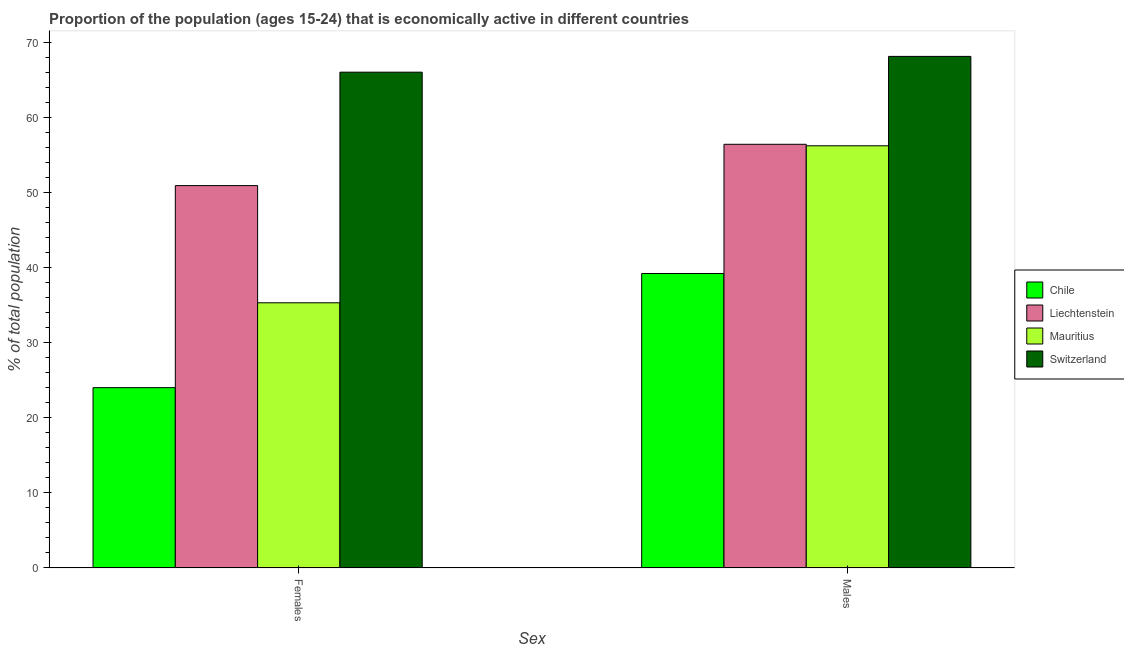How many groups of bars are there?
Ensure brevity in your answer.  2. Are the number of bars per tick equal to the number of legend labels?
Your answer should be very brief. Yes. How many bars are there on the 2nd tick from the right?
Provide a short and direct response. 4. What is the label of the 2nd group of bars from the left?
Offer a terse response. Males. Across all countries, what is the maximum percentage of economically active male population?
Your answer should be very brief. 68.1. Across all countries, what is the minimum percentage of economically active female population?
Give a very brief answer. 24. In which country was the percentage of economically active male population maximum?
Provide a short and direct response. Switzerland. What is the total percentage of economically active male population in the graph?
Offer a very short reply. 219.9. What is the difference between the percentage of economically active male population in Chile and that in Liechtenstein?
Your response must be concise. -17.2. What is the difference between the percentage of economically active female population in Chile and the percentage of economically active male population in Switzerland?
Your answer should be compact. -44.1. What is the average percentage of economically active female population per country?
Your answer should be compact. 44.05. What is the difference between the percentage of economically active male population and percentage of economically active female population in Mauritius?
Offer a very short reply. 20.9. What is the ratio of the percentage of economically active male population in Liechtenstein to that in Chile?
Your answer should be compact. 1.44. What does the 2nd bar from the left in Females represents?
Give a very brief answer. Liechtenstein. What does the 1st bar from the right in Females represents?
Make the answer very short. Switzerland. How many bars are there?
Your response must be concise. 8. Are all the bars in the graph horizontal?
Your answer should be very brief. No. Are the values on the major ticks of Y-axis written in scientific E-notation?
Keep it short and to the point. No. How are the legend labels stacked?
Offer a very short reply. Vertical. What is the title of the graph?
Ensure brevity in your answer.  Proportion of the population (ages 15-24) that is economically active in different countries. What is the label or title of the X-axis?
Keep it short and to the point. Sex. What is the label or title of the Y-axis?
Your answer should be very brief. % of total population. What is the % of total population of Chile in Females?
Your answer should be compact. 24. What is the % of total population in Liechtenstein in Females?
Your answer should be very brief. 50.9. What is the % of total population of Mauritius in Females?
Ensure brevity in your answer.  35.3. What is the % of total population in Chile in Males?
Ensure brevity in your answer.  39.2. What is the % of total population of Liechtenstein in Males?
Your answer should be very brief. 56.4. What is the % of total population in Mauritius in Males?
Give a very brief answer. 56.2. What is the % of total population of Switzerland in Males?
Make the answer very short. 68.1. Across all Sex, what is the maximum % of total population of Chile?
Your answer should be compact. 39.2. Across all Sex, what is the maximum % of total population of Liechtenstein?
Offer a very short reply. 56.4. Across all Sex, what is the maximum % of total population in Mauritius?
Your response must be concise. 56.2. Across all Sex, what is the maximum % of total population of Switzerland?
Provide a succinct answer. 68.1. Across all Sex, what is the minimum % of total population of Chile?
Keep it short and to the point. 24. Across all Sex, what is the minimum % of total population in Liechtenstein?
Ensure brevity in your answer.  50.9. Across all Sex, what is the minimum % of total population of Mauritius?
Provide a succinct answer. 35.3. Across all Sex, what is the minimum % of total population of Switzerland?
Give a very brief answer. 66. What is the total % of total population in Chile in the graph?
Make the answer very short. 63.2. What is the total % of total population in Liechtenstein in the graph?
Give a very brief answer. 107.3. What is the total % of total population in Mauritius in the graph?
Keep it short and to the point. 91.5. What is the total % of total population in Switzerland in the graph?
Give a very brief answer. 134.1. What is the difference between the % of total population in Chile in Females and that in Males?
Offer a terse response. -15.2. What is the difference between the % of total population of Liechtenstein in Females and that in Males?
Offer a very short reply. -5.5. What is the difference between the % of total population of Mauritius in Females and that in Males?
Your response must be concise. -20.9. What is the difference between the % of total population of Chile in Females and the % of total population of Liechtenstein in Males?
Ensure brevity in your answer.  -32.4. What is the difference between the % of total population of Chile in Females and the % of total population of Mauritius in Males?
Your answer should be very brief. -32.2. What is the difference between the % of total population in Chile in Females and the % of total population in Switzerland in Males?
Provide a short and direct response. -44.1. What is the difference between the % of total population in Liechtenstein in Females and the % of total population in Mauritius in Males?
Provide a succinct answer. -5.3. What is the difference between the % of total population in Liechtenstein in Females and the % of total population in Switzerland in Males?
Your response must be concise. -17.2. What is the difference between the % of total population in Mauritius in Females and the % of total population in Switzerland in Males?
Provide a short and direct response. -32.8. What is the average % of total population of Chile per Sex?
Your response must be concise. 31.6. What is the average % of total population in Liechtenstein per Sex?
Make the answer very short. 53.65. What is the average % of total population of Mauritius per Sex?
Offer a very short reply. 45.75. What is the average % of total population in Switzerland per Sex?
Your answer should be very brief. 67.05. What is the difference between the % of total population in Chile and % of total population in Liechtenstein in Females?
Your answer should be very brief. -26.9. What is the difference between the % of total population in Chile and % of total population in Switzerland in Females?
Make the answer very short. -42. What is the difference between the % of total population in Liechtenstein and % of total population in Switzerland in Females?
Ensure brevity in your answer.  -15.1. What is the difference between the % of total population of Mauritius and % of total population of Switzerland in Females?
Offer a terse response. -30.7. What is the difference between the % of total population in Chile and % of total population in Liechtenstein in Males?
Give a very brief answer. -17.2. What is the difference between the % of total population of Chile and % of total population of Mauritius in Males?
Offer a very short reply. -17. What is the difference between the % of total population in Chile and % of total population in Switzerland in Males?
Make the answer very short. -28.9. What is the difference between the % of total population of Liechtenstein and % of total population of Mauritius in Males?
Keep it short and to the point. 0.2. What is the ratio of the % of total population of Chile in Females to that in Males?
Provide a succinct answer. 0.61. What is the ratio of the % of total population of Liechtenstein in Females to that in Males?
Offer a very short reply. 0.9. What is the ratio of the % of total population in Mauritius in Females to that in Males?
Provide a succinct answer. 0.63. What is the ratio of the % of total population of Switzerland in Females to that in Males?
Give a very brief answer. 0.97. What is the difference between the highest and the second highest % of total population in Liechtenstein?
Provide a short and direct response. 5.5. What is the difference between the highest and the second highest % of total population in Mauritius?
Your response must be concise. 20.9. What is the difference between the highest and the second highest % of total population of Switzerland?
Provide a succinct answer. 2.1. What is the difference between the highest and the lowest % of total population in Chile?
Your response must be concise. 15.2. What is the difference between the highest and the lowest % of total population in Mauritius?
Your response must be concise. 20.9. 